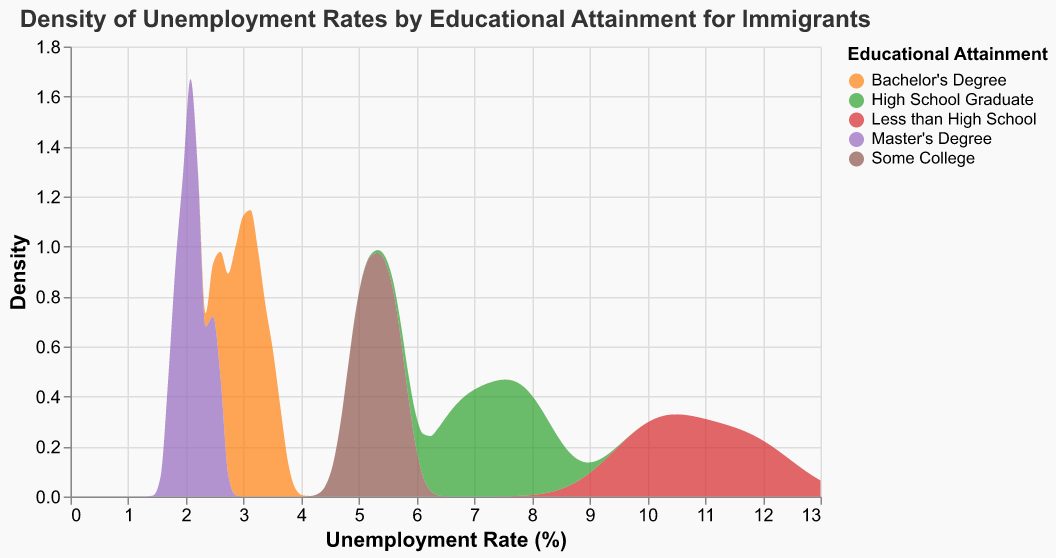What is the title of the plot? The title is usually written at the top of the plot and can be easily read directly. The title of the plot is "Density of Unemployment Rates by Educational Attainment for Immigrants".
Answer: Density of Unemployment Rates by Educational Attainment for Immigrants Which educational attainment level has the highest peak density in their unemployment rate distribution? By looking at the highest peaks of each density curve, "Less than High School" shows the highest peak density.
Answer: Less than High School What is the range of unemployment rates considered in the plot? The x-axis labeled "Unemployment Rate (%)" shows the range, which starts at 0% and goes up to 13%.
Answer: 0 to 13% How do the unemployment rates for those with a Master's Degree compare to those with a Bachelor's Degree? The unemployment rates for Master's Degree holders are generally lower, with most rates under 2.5%, whereas Bachelor's Degree holders have rates mostly below 3.5%.
Answer: Lower Which group has the lowest range of observed unemployment rates? By considering the span of each group's density plot along the x-axis, "Master's Degree" holders have the most concentrated and lowest range of unemployment rates, from about 1.8% to 2.5%.
Answer: Master's Degree Which educational attainment level group has the widest spread of unemployment rates in the density plot? By looking at how spread out each density plot is on the x-axis, "Less than High School" has the widest spread, covering from around 9.8% to 12.1%.
Answer: Less than High School What is the approximate peak density value for the group with Some College education? Each density plot has a peak, and the "Some College" group reaches a peak density of about 0.6 at around 5.1% unemployment rate.
Answer: 0.6 What are the primary differences in the density plots between High School Graduates and those with Some College education? "High School Graduate" unemployment rates spread from roughly 6.5% to 8.1%, whereas "Some College" rates span a tighter range of about 4.9% to 5.7%, with peaks showing that "High School Graduate" rates are generally higher.
Answer: High School Graduates have higher unemployment rates and a wider spread What general trend is observable between educational attainment and unemployment rates among the immigrant groups? Higher educational attainment is associated with lower unemployment rates. This trend shows in the progressive leftward shift and narrowing of density curves moving from "Less than High School" to "Master's Degree".
Answer: Higher education correlates with lower unemployment rates What is the overlapping range of unemployment rates for Bachelor's Degree and Master's Degree holders? By comparing the density plots, the overlapping range for both Bachelor's Degree and Master's Degree holders is roughly from 2.0% to 2.5% unemployment rate.
Answer: 2.0% to 2.5% 